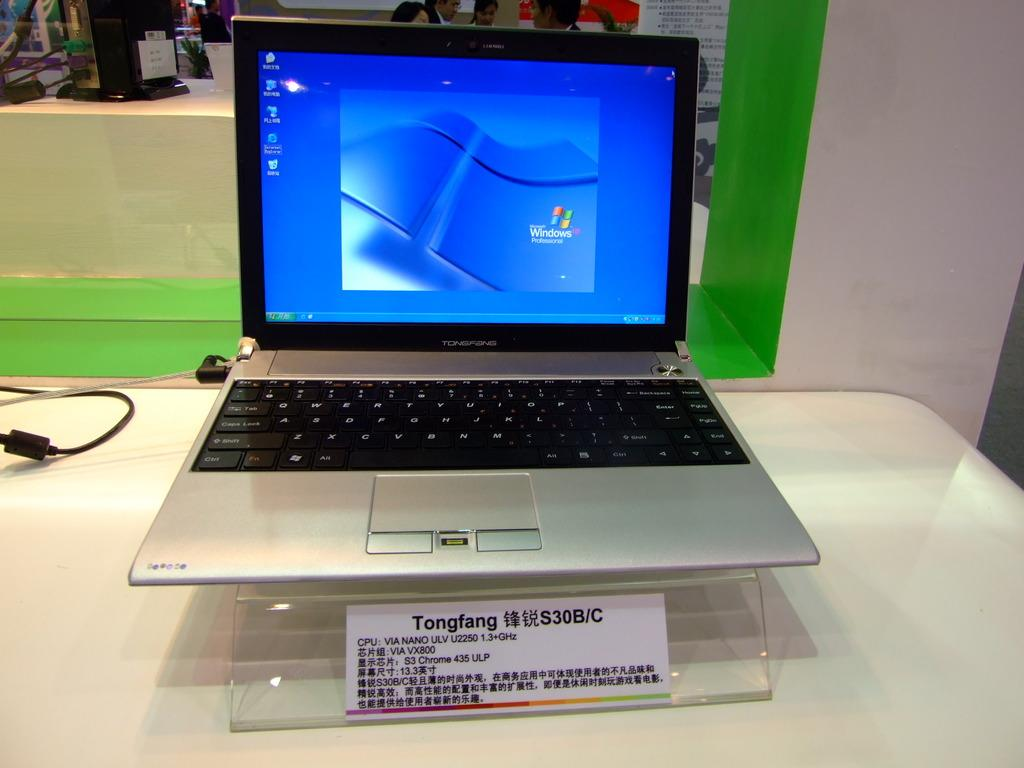<image>
Relay a brief, clear account of the picture shown. the word Windows is on a laptop screen 